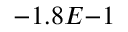Convert formula to latex. <formula><loc_0><loc_0><loc_500><loc_500>- 1 . 8 E { - 1 }</formula> 